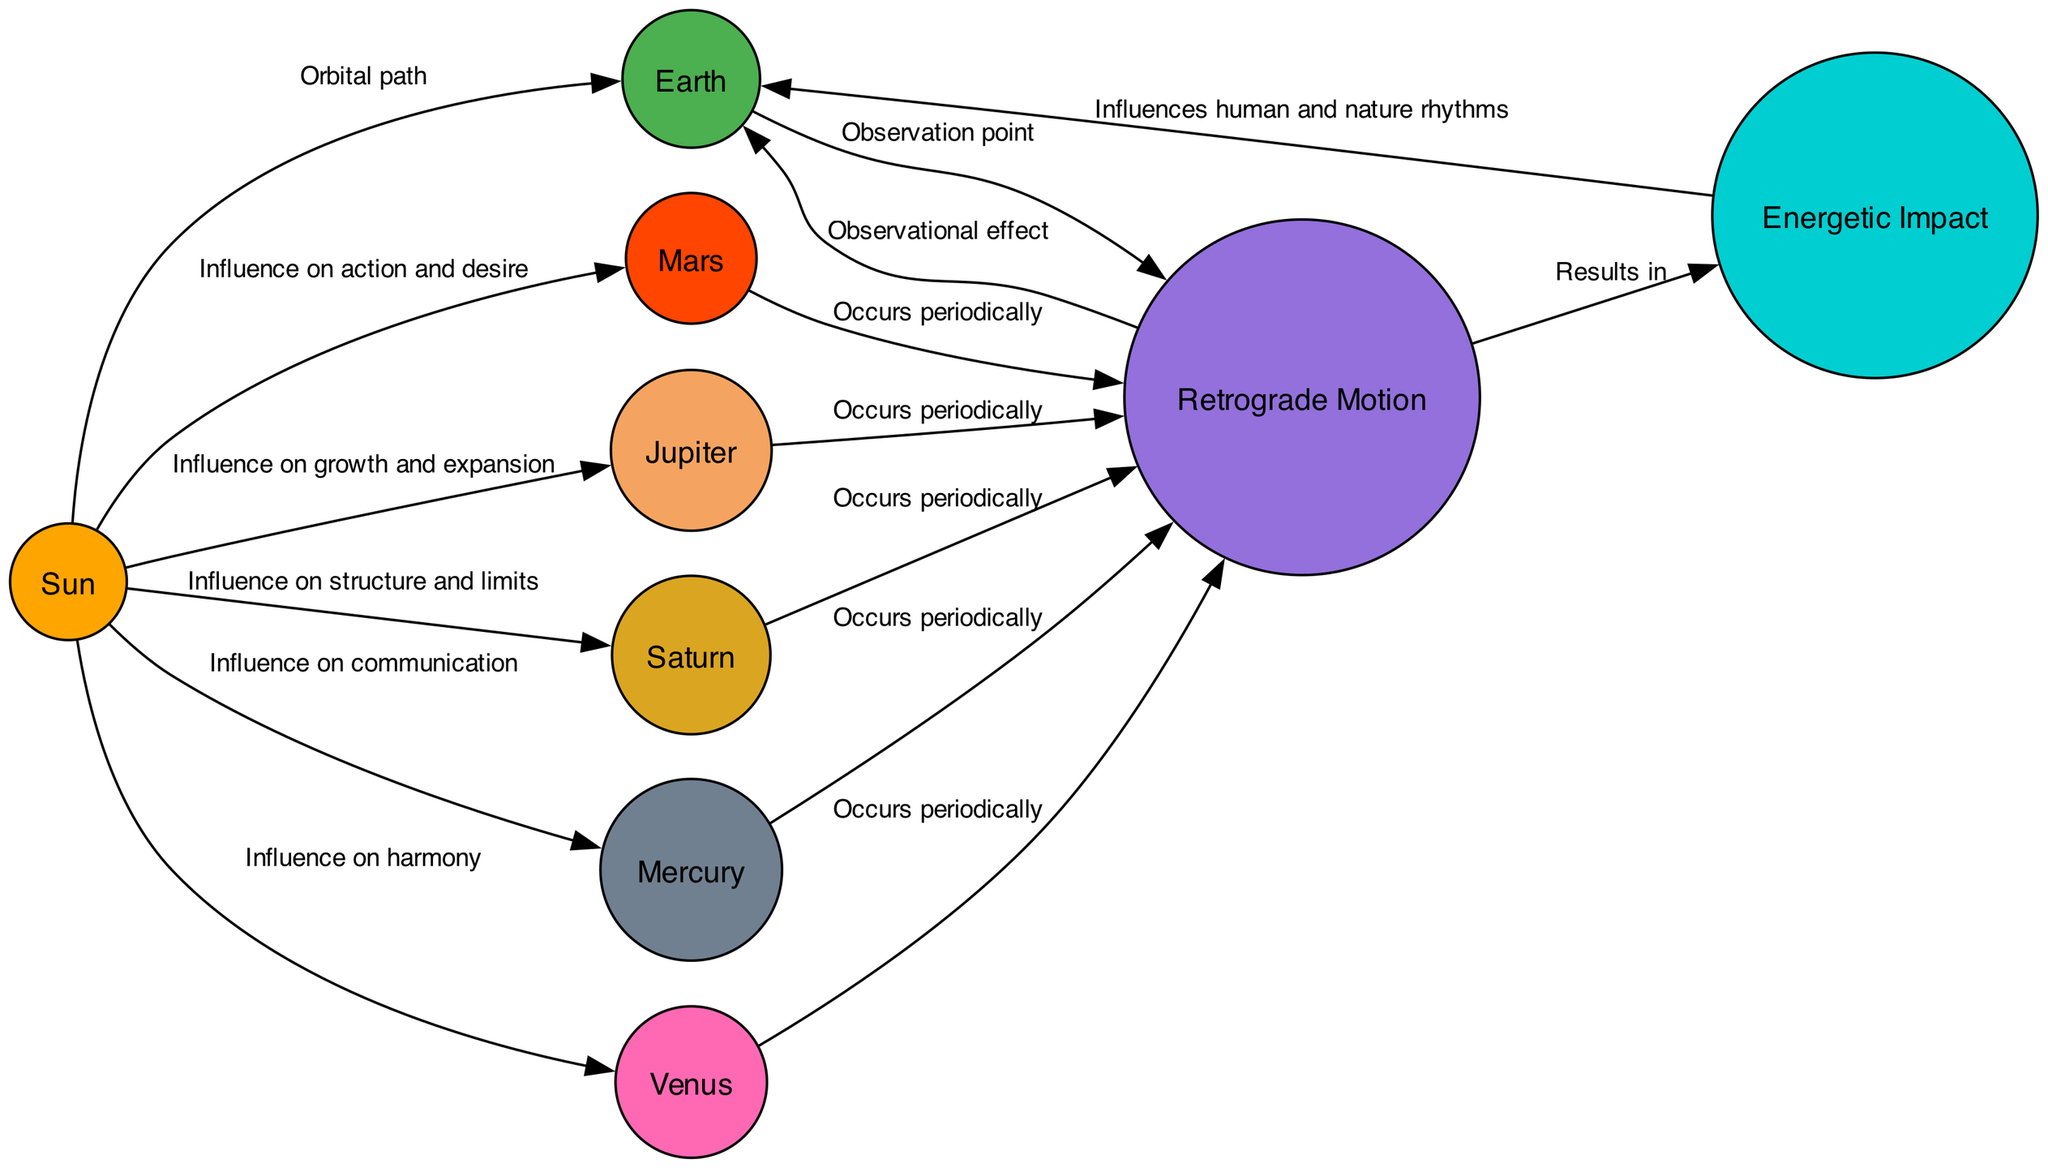What is at the center of the solar system? The center of the solar system is the Sun, which is designated as the main source of light and energy in the diagram.
Answer: Sun How many planets are illustrated in the diagram? The diagram features six planets: Earth, Mars, Jupiter, Saturn, Mercury, and Venus, which can be counted from the nodes section of the diagram.
Answer: Six What does "Retrograde Motion" indicate in the diagram? "Retrograde Motion" refers to the apparent backward motion of planets, as represented by the labeled node in the diagram.
Answer: Apparent backward motion How does Mars relate to Retrograde Motion? Mars is shown to periodically undergo retrograde motion, as indicated by the edge connecting Mars to Retrograde, representing this relationship in the diagram.
Answer: Occurs periodically Which planetary influence is associated with love and harmony? Venus is the planet associated with love and harmony, as described in the node's information.
Answer: Venus What is the relationship between Retrograde and Energetic Impact? Retrograde leads to Energetic Impact, as indicated by the directed edge between these two nodes in the diagram.
Answer: Results in Which planet's influence is linked to growth and expansion? Jupiter is linked to growth and expansion, evidenced by the edge connecting it with the Sun showing its influence in that aspect.
Answer: Jupiter What is the observational effect of Retrograde on Earth? The observational effect of Retrograde on Earth is described directly in the diagram, linking Retrograde to Earth with an edge labeled "Observational effect."
Answer: Observational effect How do planetary retrogrades influence human and nature rhythms? The influence of retrogrades on human and nature rhythms is described in the diagram as an impact from the connected node "Energetic Impact" leading to Earth.
Answer: Influences human and nature rhythms 